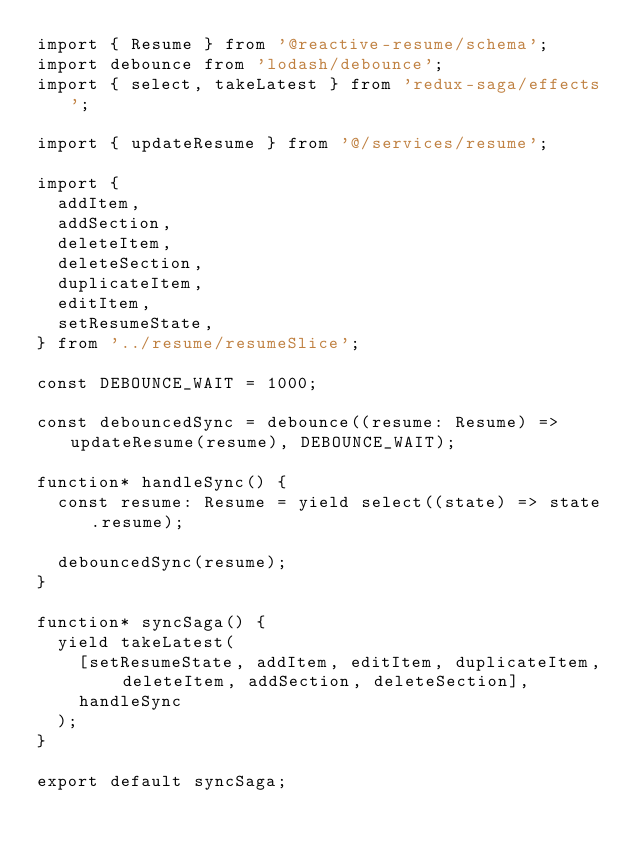<code> <loc_0><loc_0><loc_500><loc_500><_TypeScript_>import { Resume } from '@reactive-resume/schema';
import debounce from 'lodash/debounce';
import { select, takeLatest } from 'redux-saga/effects';

import { updateResume } from '@/services/resume';

import {
  addItem,
  addSection,
  deleteItem,
  deleteSection,
  duplicateItem,
  editItem,
  setResumeState,
} from '../resume/resumeSlice';

const DEBOUNCE_WAIT = 1000;

const debouncedSync = debounce((resume: Resume) => updateResume(resume), DEBOUNCE_WAIT);

function* handleSync() {
  const resume: Resume = yield select((state) => state.resume);

  debouncedSync(resume);
}

function* syncSaga() {
  yield takeLatest(
    [setResumeState, addItem, editItem, duplicateItem, deleteItem, addSection, deleteSection],
    handleSync
  );
}

export default syncSaga;
</code> 